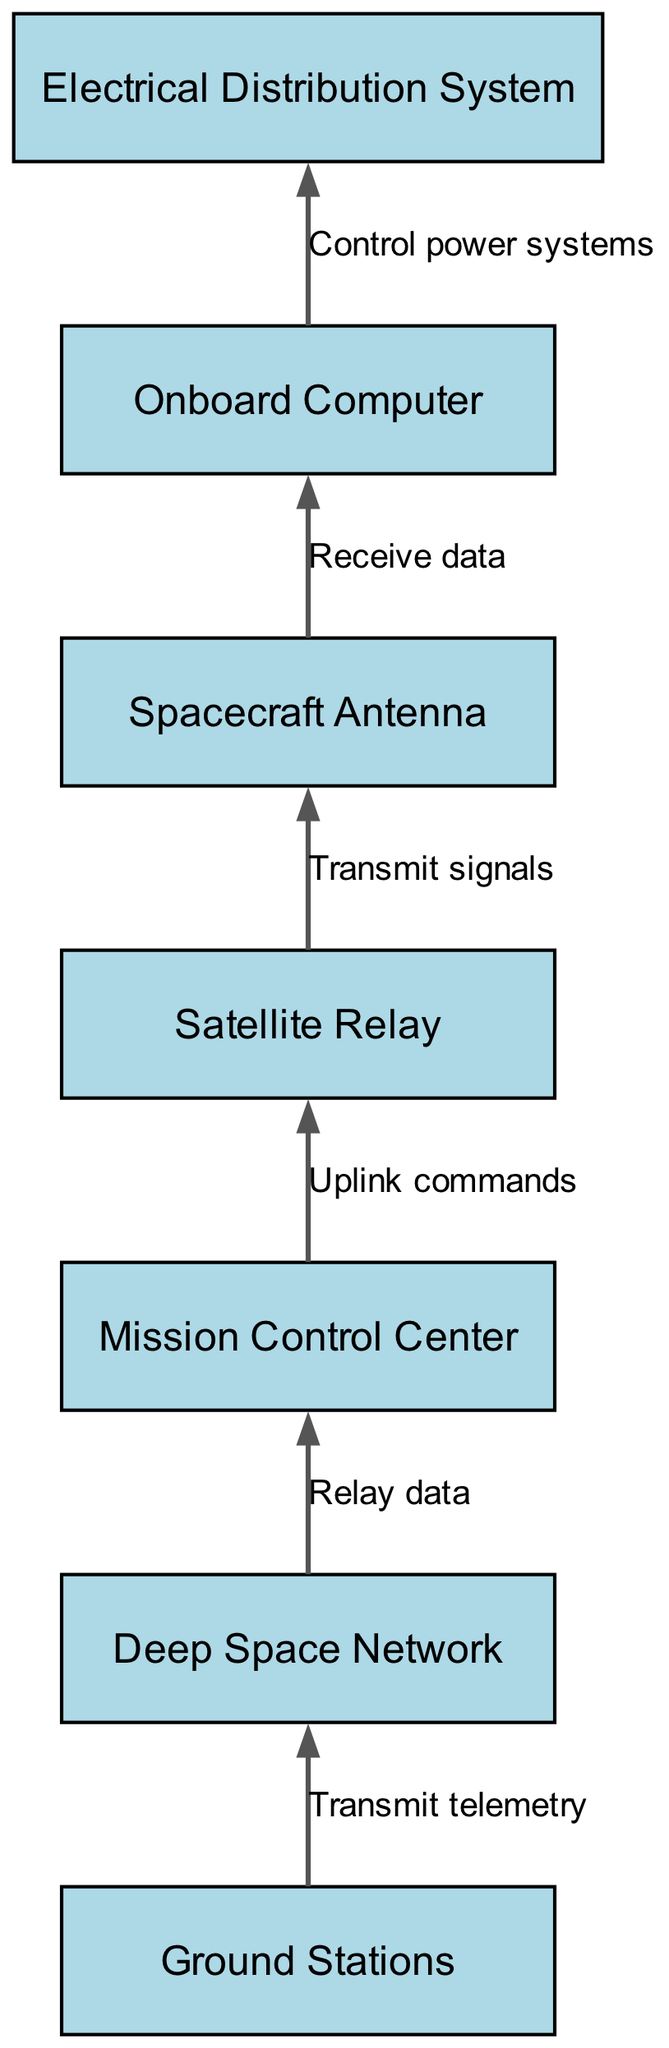What are the nodes in the diagram? The diagram contains seven distinct nodes: Ground Stations, Deep Space Network, Mission Control Center, Satellite Relay, Spacecraft Antenna, Onboard Computer, and Electrical Distribution System.
Answer: Ground Stations, Deep Space Network, Mission Control Center, Satellite Relay, Spacecraft Antenna, Onboard Computer, Electrical Distribution System How many edges are there? The diagram shows six edges connecting various nodes, indicating the flow of data and commands between them.
Answer: 6 What is the relationship between the Ground Stations and the Deep Space Network? The Ground Stations transmit telemetry data to the Deep Space Network, indicating a direct flow of information from one to the other.
Answer: Transmit telemetry What is the last node in the data flow? The last node indicating the final endpoint of the data flow is the Electrical Distribution System, which is controlled by the Onboard Computer.
Answer: Electrical Distribution System What type of data does the Mission Control Center send to the Satellite Relay? The Mission Control Center uplinks commands to the Satellite Relay, indicating the type of information being transmitted in that direction.
Answer: Uplink commands Which node directly receives data from the Spacecraft Antenna? The Onboard Computer is the node that directly receives the data transmitted from the Spacecraft Antenna.
Answer: Onboard Computer What is the function of the Electrical Distribution System in this flow? The Electrical Distribution System's function is to control power systems, showing its role in managing energy based on the data it receives from the Onboard Computer.
Answer: Control power systems Which node acts as the intermediary between the Ground Stations and the Mission Control Center? The Deep Space Network acts as the intermediary, relaying data from the Ground Stations before it reaches the Mission Control Center.
Answer: Deep Space Network According to the flow chart, which component initiates the data flow? The data flow is initiated by the Ground Stations, which start the process by transmitting telemetry data.
Answer: Ground Stations 